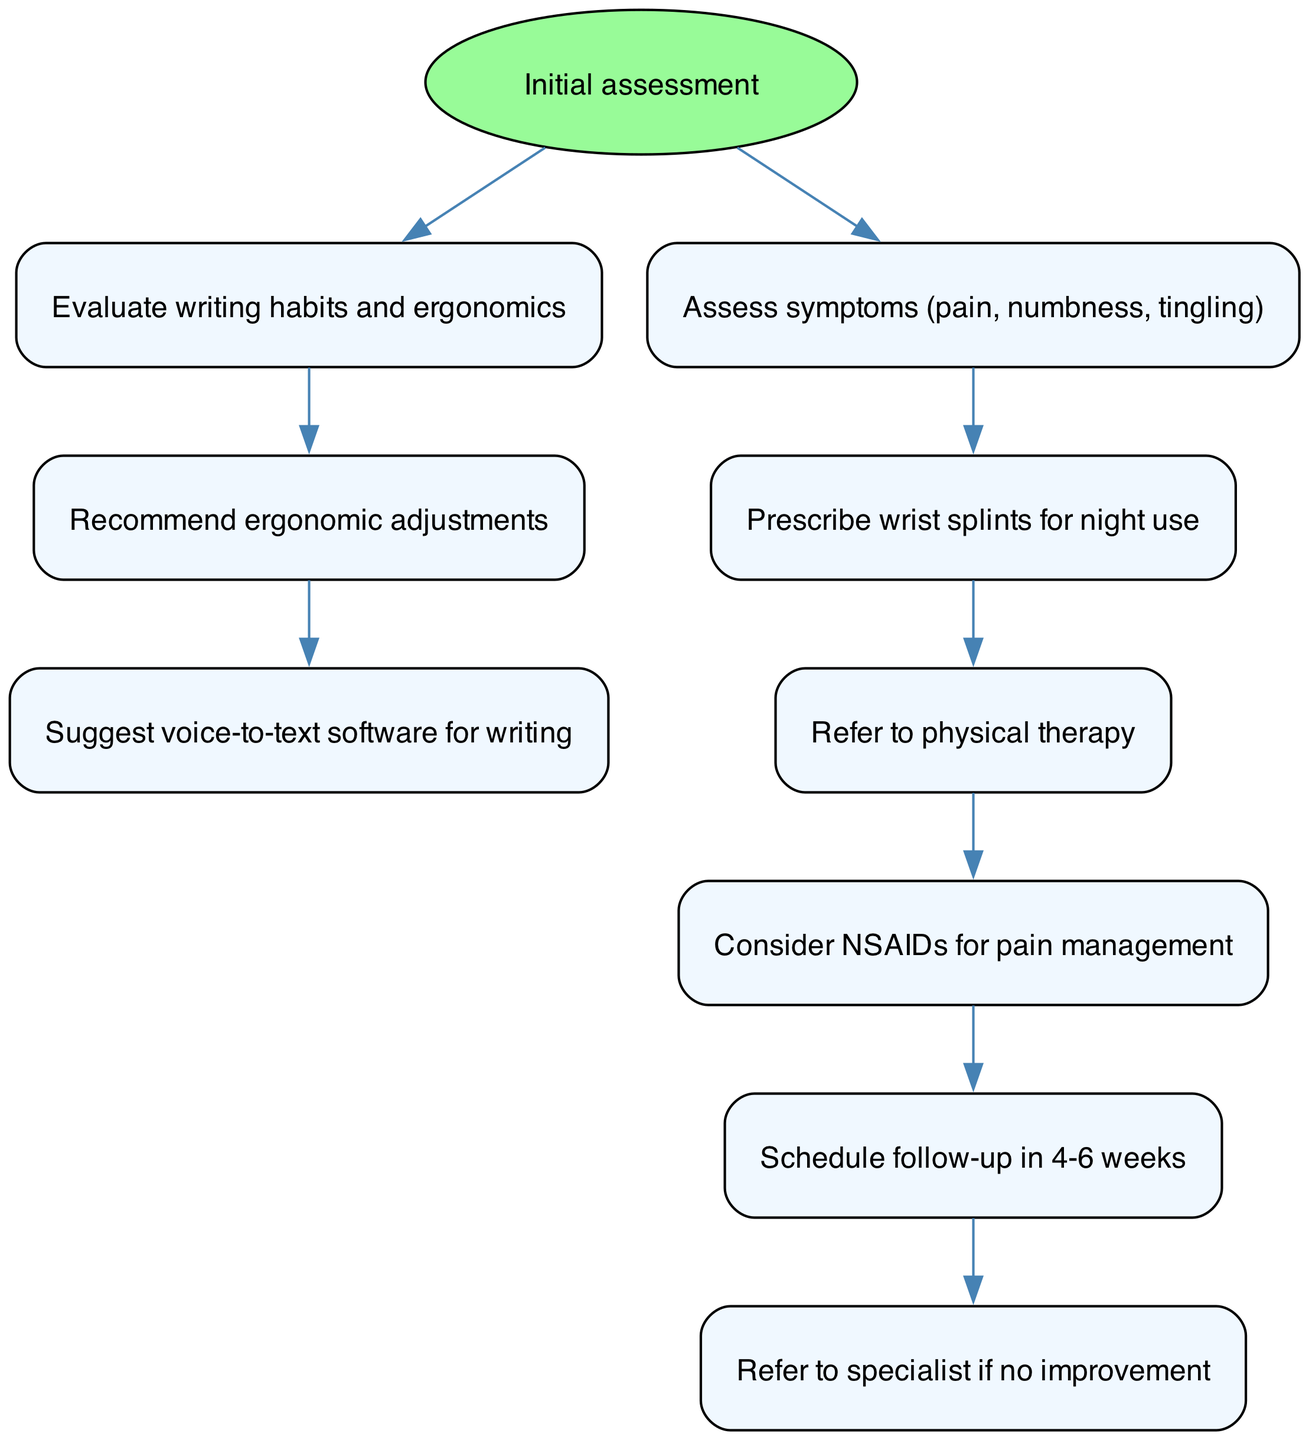What is the start point of the clinical pathway? The start point of the clinical pathway is explicitly labeled in the diagram as "Initial assessment."
Answer: Initial assessment How many nodes are present in the diagram? By counting the individual nodes listed in the data, there are a total of nine nodes provided in the clinical pathway.
Answer: 9 What is the last node in the diagram? The last node is determined by following the edges and observing that the final connection leads to "Refer to specialist if no improvement."
Answer: Refer to specialist if no improvement What node follows the assessment of symptoms? To find which node follows "Assess symptoms (pain, numbness, tingling)," I check the directed edges and see that it connects to "Prescribe wrist splints for night use."
Answer: Prescribe wrist splints for night use Which ergonomic adjustment is recommended after evaluating writing habits? Following the node "Evaluate writing habits and ergonomics," the next node is "Recommend ergonomic adjustments," thus capturing the recommended action for ergonomics.
Answer: Recommend ergonomic adjustments How long should the follow-up be scheduled after the initial assessment? The node connected to the scheduling follow-up indicates it should be in "4-6 weeks" after other assessments and interventions along the pathway.
Answer: 4-6 weeks What is one suggested alternative to reduce writing strain? The node "Suggest voice-to-text software for writing" indicates an alternative strategy to help reduce physical strain associated with writing.
Answer: Suggest voice-to-text software for writing After prescribing wrist splints, which action follows next? Analyzing the edge connections, I find that "Refer to physical therapy" follows immediately after prescribing wrist splints for night use, indicating the next step in the process.
Answer: Refer to physical therapy What is recommended for pain management during the pathway? The node "Consider NSAIDs for pain management" specifically provides a suggestion for managing pain associated with the condition being treated.
Answer: Consider NSAIDs for pain management 